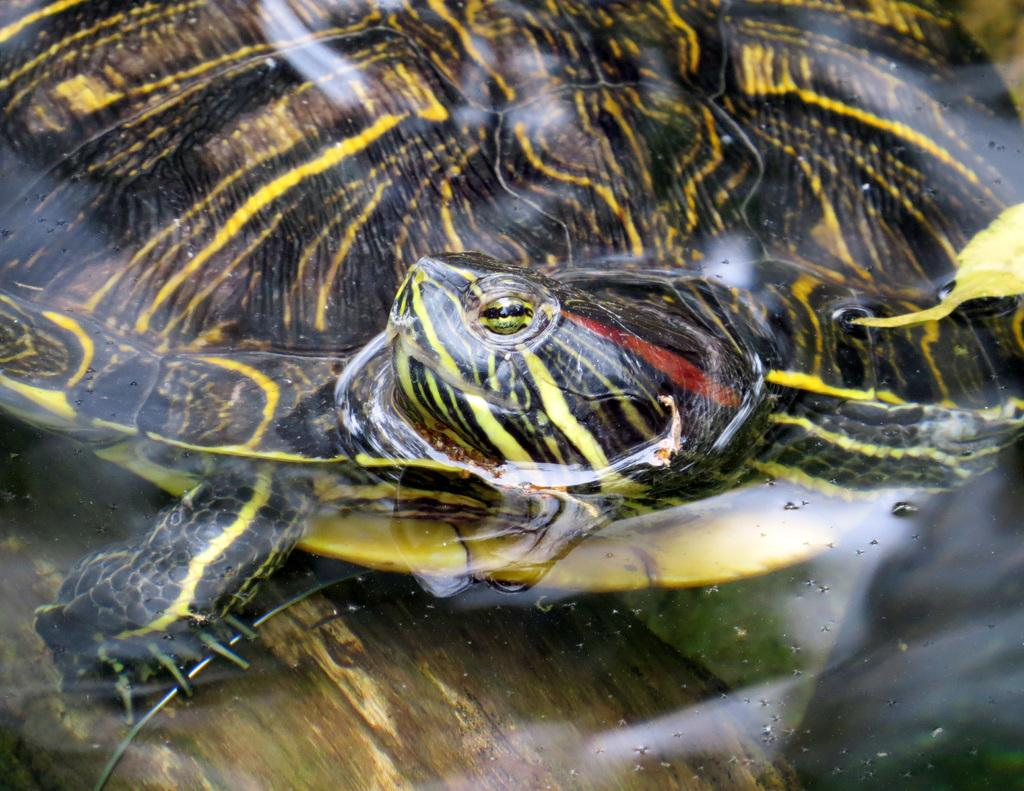What is the main subject in the image? There is a turtle-like object in the image. Can you describe the object in the foreground? There is an object in the foreground that resembles the ground. What type of honey is being produced by the turtle-like object in the image? There is no honey or turtle-like object producing honey present in the image. 